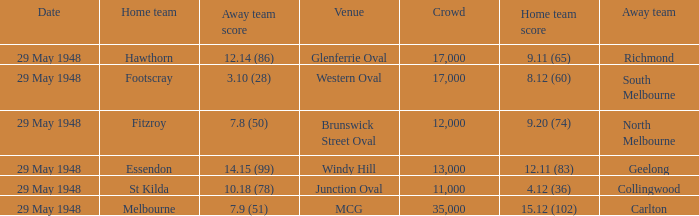In the match where north melbourne was the away team, how much did the home team score? 9.20 (74). 